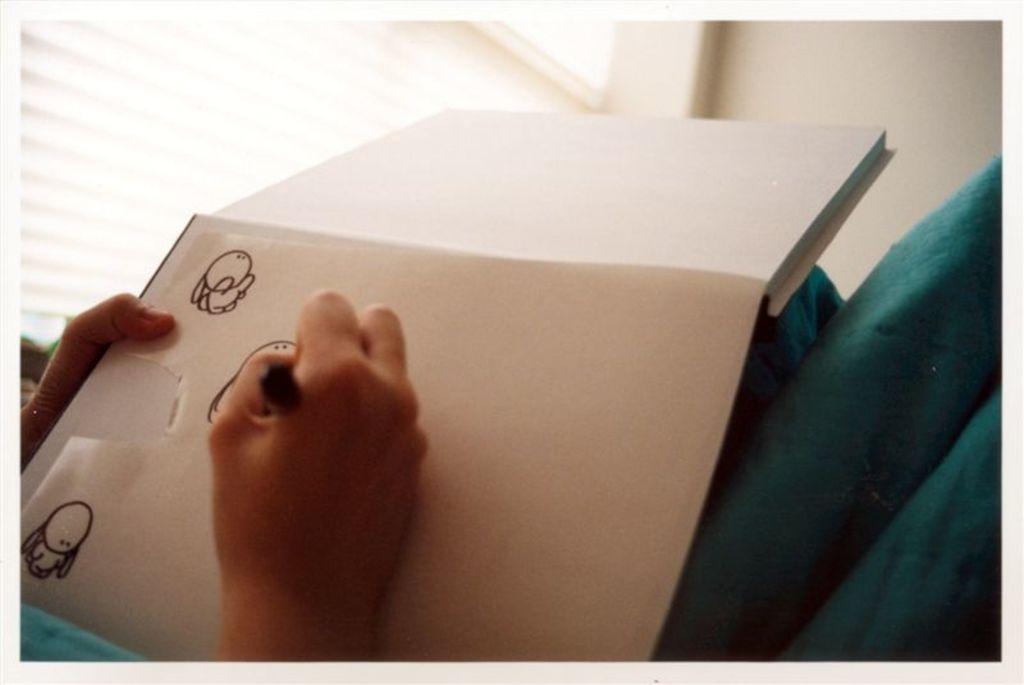Can you describe this image briefly? This image consists of a person drawing in the book. To the left, there is a window. In the background, there is a wall in white color. 